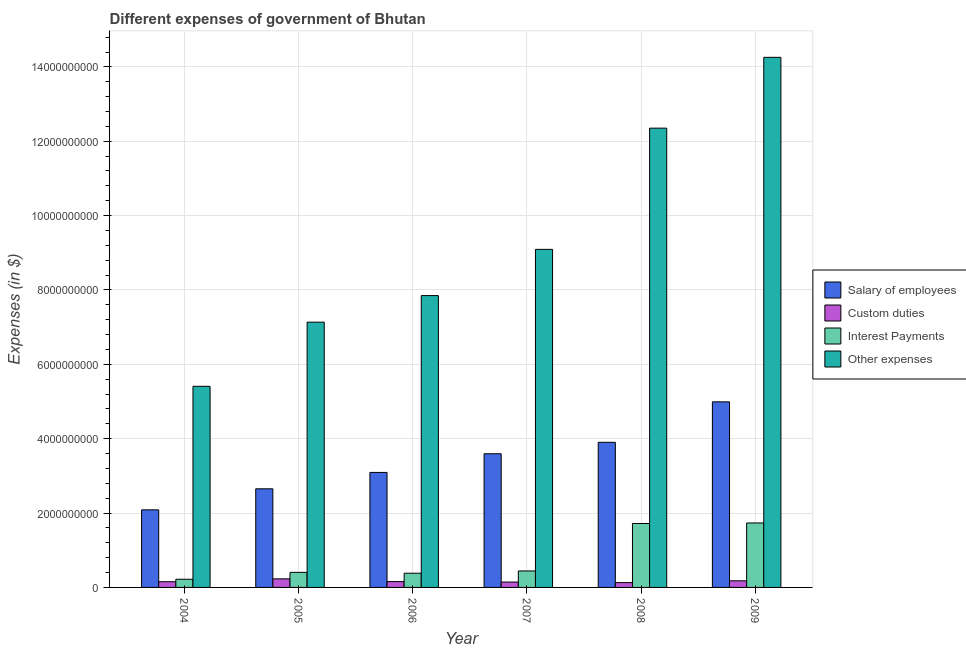How many different coloured bars are there?
Make the answer very short. 4. Are the number of bars per tick equal to the number of legend labels?
Provide a short and direct response. Yes. Are the number of bars on each tick of the X-axis equal?
Provide a short and direct response. Yes. How many bars are there on the 5th tick from the right?
Your answer should be compact. 4. What is the label of the 2nd group of bars from the left?
Offer a very short reply. 2005. What is the amount spent on other expenses in 2004?
Give a very brief answer. 5.41e+09. Across all years, what is the maximum amount spent on other expenses?
Your answer should be compact. 1.43e+1. Across all years, what is the minimum amount spent on other expenses?
Your answer should be very brief. 5.41e+09. In which year was the amount spent on custom duties maximum?
Provide a short and direct response. 2005. In which year was the amount spent on salary of employees minimum?
Offer a terse response. 2004. What is the total amount spent on custom duties in the graph?
Your response must be concise. 9.93e+08. What is the difference between the amount spent on custom duties in 2005 and that in 2009?
Give a very brief answer. 5.28e+07. What is the difference between the amount spent on salary of employees in 2005 and the amount spent on custom duties in 2004?
Keep it short and to the point. 5.66e+08. What is the average amount spent on interest payments per year?
Offer a very short reply. 8.17e+08. In the year 2005, what is the difference between the amount spent on salary of employees and amount spent on custom duties?
Provide a succinct answer. 0. What is the ratio of the amount spent on other expenses in 2004 to that in 2009?
Provide a succinct answer. 0.38. Is the amount spent on custom duties in 2006 less than that in 2007?
Make the answer very short. No. What is the difference between the highest and the second highest amount spent on custom duties?
Your response must be concise. 5.28e+07. What is the difference between the highest and the lowest amount spent on interest payments?
Your answer should be very brief. 1.51e+09. Is it the case that in every year, the sum of the amount spent on salary of employees and amount spent on interest payments is greater than the sum of amount spent on other expenses and amount spent on custom duties?
Your answer should be compact. Yes. What does the 4th bar from the left in 2006 represents?
Keep it short and to the point. Other expenses. What does the 1st bar from the right in 2006 represents?
Your answer should be compact. Other expenses. Is it the case that in every year, the sum of the amount spent on salary of employees and amount spent on custom duties is greater than the amount spent on interest payments?
Your answer should be very brief. Yes. How many bars are there?
Offer a terse response. 24. What is the difference between two consecutive major ticks on the Y-axis?
Provide a short and direct response. 2.00e+09. Are the values on the major ticks of Y-axis written in scientific E-notation?
Your answer should be very brief. No. Does the graph contain any zero values?
Your response must be concise. No. Where does the legend appear in the graph?
Give a very brief answer. Center right. What is the title of the graph?
Give a very brief answer. Different expenses of government of Bhutan. What is the label or title of the Y-axis?
Provide a short and direct response. Expenses (in $). What is the Expenses (in $) of Salary of employees in 2004?
Your response must be concise. 2.09e+09. What is the Expenses (in $) of Custom duties in 2004?
Ensure brevity in your answer.  1.53e+08. What is the Expenses (in $) in Interest Payments in 2004?
Keep it short and to the point. 2.20e+08. What is the Expenses (in $) of Other expenses in 2004?
Keep it short and to the point. 5.41e+09. What is the Expenses (in $) of Salary of employees in 2005?
Provide a short and direct response. 2.65e+09. What is the Expenses (in $) of Custom duties in 2005?
Give a very brief answer. 2.31e+08. What is the Expenses (in $) in Interest Payments in 2005?
Provide a short and direct response. 4.05e+08. What is the Expenses (in $) in Other expenses in 2005?
Keep it short and to the point. 7.13e+09. What is the Expenses (in $) in Salary of employees in 2006?
Your answer should be compact. 3.09e+09. What is the Expenses (in $) in Custom duties in 2006?
Provide a short and direct response. 1.57e+08. What is the Expenses (in $) of Interest Payments in 2006?
Your answer should be very brief. 3.82e+08. What is the Expenses (in $) in Other expenses in 2006?
Give a very brief answer. 7.85e+09. What is the Expenses (in $) in Salary of employees in 2007?
Make the answer very short. 3.60e+09. What is the Expenses (in $) of Custom duties in 2007?
Ensure brevity in your answer.  1.45e+08. What is the Expenses (in $) of Interest Payments in 2007?
Keep it short and to the point. 4.43e+08. What is the Expenses (in $) in Other expenses in 2007?
Make the answer very short. 9.09e+09. What is the Expenses (in $) of Salary of employees in 2008?
Provide a succinct answer. 3.90e+09. What is the Expenses (in $) in Custom duties in 2008?
Give a very brief answer. 1.29e+08. What is the Expenses (in $) in Interest Payments in 2008?
Keep it short and to the point. 1.72e+09. What is the Expenses (in $) of Other expenses in 2008?
Your answer should be compact. 1.24e+1. What is the Expenses (in $) of Salary of employees in 2009?
Your answer should be very brief. 4.99e+09. What is the Expenses (in $) in Custom duties in 2009?
Your answer should be very brief. 1.78e+08. What is the Expenses (in $) of Interest Payments in 2009?
Provide a short and direct response. 1.73e+09. What is the Expenses (in $) of Other expenses in 2009?
Offer a terse response. 1.43e+1. Across all years, what is the maximum Expenses (in $) of Salary of employees?
Provide a short and direct response. 4.99e+09. Across all years, what is the maximum Expenses (in $) of Custom duties?
Offer a very short reply. 2.31e+08. Across all years, what is the maximum Expenses (in $) of Interest Payments?
Ensure brevity in your answer.  1.73e+09. Across all years, what is the maximum Expenses (in $) in Other expenses?
Your response must be concise. 1.43e+1. Across all years, what is the minimum Expenses (in $) in Salary of employees?
Offer a very short reply. 2.09e+09. Across all years, what is the minimum Expenses (in $) in Custom duties?
Ensure brevity in your answer.  1.29e+08. Across all years, what is the minimum Expenses (in $) of Interest Payments?
Your answer should be compact. 2.20e+08. Across all years, what is the minimum Expenses (in $) in Other expenses?
Offer a terse response. 5.41e+09. What is the total Expenses (in $) of Salary of employees in the graph?
Provide a short and direct response. 2.03e+1. What is the total Expenses (in $) of Custom duties in the graph?
Give a very brief answer. 9.93e+08. What is the total Expenses (in $) in Interest Payments in the graph?
Your response must be concise. 4.90e+09. What is the total Expenses (in $) of Other expenses in the graph?
Keep it short and to the point. 5.61e+1. What is the difference between the Expenses (in $) of Salary of employees in 2004 and that in 2005?
Provide a succinct answer. -5.66e+08. What is the difference between the Expenses (in $) in Custom duties in 2004 and that in 2005?
Your answer should be compact. -7.75e+07. What is the difference between the Expenses (in $) of Interest Payments in 2004 and that in 2005?
Your answer should be compact. -1.85e+08. What is the difference between the Expenses (in $) in Other expenses in 2004 and that in 2005?
Offer a very short reply. -1.72e+09. What is the difference between the Expenses (in $) of Salary of employees in 2004 and that in 2006?
Offer a very short reply. -1.01e+09. What is the difference between the Expenses (in $) in Custom duties in 2004 and that in 2006?
Offer a terse response. -3.86e+06. What is the difference between the Expenses (in $) of Interest Payments in 2004 and that in 2006?
Your response must be concise. -1.62e+08. What is the difference between the Expenses (in $) of Other expenses in 2004 and that in 2006?
Your answer should be compact. -2.44e+09. What is the difference between the Expenses (in $) in Salary of employees in 2004 and that in 2007?
Give a very brief answer. -1.51e+09. What is the difference between the Expenses (in $) in Custom duties in 2004 and that in 2007?
Your answer should be very brief. 8.63e+06. What is the difference between the Expenses (in $) in Interest Payments in 2004 and that in 2007?
Offer a very short reply. -2.23e+08. What is the difference between the Expenses (in $) in Other expenses in 2004 and that in 2007?
Offer a terse response. -3.68e+09. What is the difference between the Expenses (in $) of Salary of employees in 2004 and that in 2008?
Ensure brevity in your answer.  -1.82e+09. What is the difference between the Expenses (in $) in Custom duties in 2004 and that in 2008?
Your answer should be very brief. 2.38e+07. What is the difference between the Expenses (in $) of Interest Payments in 2004 and that in 2008?
Ensure brevity in your answer.  -1.50e+09. What is the difference between the Expenses (in $) of Other expenses in 2004 and that in 2008?
Your answer should be very brief. -6.94e+09. What is the difference between the Expenses (in $) in Salary of employees in 2004 and that in 2009?
Provide a succinct answer. -2.90e+09. What is the difference between the Expenses (in $) of Custom duties in 2004 and that in 2009?
Ensure brevity in your answer.  -2.46e+07. What is the difference between the Expenses (in $) of Interest Payments in 2004 and that in 2009?
Ensure brevity in your answer.  -1.51e+09. What is the difference between the Expenses (in $) in Other expenses in 2004 and that in 2009?
Make the answer very short. -8.85e+09. What is the difference between the Expenses (in $) of Salary of employees in 2005 and that in 2006?
Your answer should be very brief. -4.40e+08. What is the difference between the Expenses (in $) of Custom duties in 2005 and that in 2006?
Keep it short and to the point. 7.36e+07. What is the difference between the Expenses (in $) in Interest Payments in 2005 and that in 2006?
Provide a short and direct response. 2.33e+07. What is the difference between the Expenses (in $) of Other expenses in 2005 and that in 2006?
Give a very brief answer. -7.15e+08. What is the difference between the Expenses (in $) of Salary of employees in 2005 and that in 2007?
Give a very brief answer. -9.43e+08. What is the difference between the Expenses (in $) of Custom duties in 2005 and that in 2007?
Give a very brief answer. 8.61e+07. What is the difference between the Expenses (in $) in Interest Payments in 2005 and that in 2007?
Offer a very short reply. -3.78e+07. What is the difference between the Expenses (in $) in Other expenses in 2005 and that in 2007?
Provide a short and direct response. -1.96e+09. What is the difference between the Expenses (in $) in Salary of employees in 2005 and that in 2008?
Provide a short and direct response. -1.25e+09. What is the difference between the Expenses (in $) in Custom duties in 2005 and that in 2008?
Offer a terse response. 1.01e+08. What is the difference between the Expenses (in $) in Interest Payments in 2005 and that in 2008?
Offer a terse response. -1.31e+09. What is the difference between the Expenses (in $) of Other expenses in 2005 and that in 2008?
Make the answer very short. -5.22e+09. What is the difference between the Expenses (in $) in Salary of employees in 2005 and that in 2009?
Offer a terse response. -2.34e+09. What is the difference between the Expenses (in $) of Custom duties in 2005 and that in 2009?
Your answer should be compact. 5.28e+07. What is the difference between the Expenses (in $) in Interest Payments in 2005 and that in 2009?
Provide a short and direct response. -1.33e+09. What is the difference between the Expenses (in $) in Other expenses in 2005 and that in 2009?
Your response must be concise. -7.12e+09. What is the difference between the Expenses (in $) of Salary of employees in 2006 and that in 2007?
Your response must be concise. -5.02e+08. What is the difference between the Expenses (in $) of Custom duties in 2006 and that in 2007?
Your answer should be compact. 1.25e+07. What is the difference between the Expenses (in $) in Interest Payments in 2006 and that in 2007?
Your answer should be compact. -6.12e+07. What is the difference between the Expenses (in $) of Other expenses in 2006 and that in 2007?
Make the answer very short. -1.24e+09. What is the difference between the Expenses (in $) of Salary of employees in 2006 and that in 2008?
Your answer should be compact. -8.10e+08. What is the difference between the Expenses (in $) in Custom duties in 2006 and that in 2008?
Offer a very short reply. 2.77e+07. What is the difference between the Expenses (in $) in Interest Payments in 2006 and that in 2008?
Ensure brevity in your answer.  -1.34e+09. What is the difference between the Expenses (in $) in Other expenses in 2006 and that in 2008?
Offer a terse response. -4.50e+09. What is the difference between the Expenses (in $) of Salary of employees in 2006 and that in 2009?
Give a very brief answer. -1.90e+09. What is the difference between the Expenses (in $) of Custom duties in 2006 and that in 2009?
Your response must be concise. -2.08e+07. What is the difference between the Expenses (in $) in Interest Payments in 2006 and that in 2009?
Offer a very short reply. -1.35e+09. What is the difference between the Expenses (in $) in Other expenses in 2006 and that in 2009?
Provide a succinct answer. -6.41e+09. What is the difference between the Expenses (in $) of Salary of employees in 2007 and that in 2008?
Provide a succinct answer. -3.08e+08. What is the difference between the Expenses (in $) in Custom duties in 2007 and that in 2008?
Your response must be concise. 1.52e+07. What is the difference between the Expenses (in $) in Interest Payments in 2007 and that in 2008?
Provide a short and direct response. -1.28e+09. What is the difference between the Expenses (in $) of Other expenses in 2007 and that in 2008?
Your response must be concise. -3.26e+09. What is the difference between the Expenses (in $) of Salary of employees in 2007 and that in 2009?
Offer a terse response. -1.40e+09. What is the difference between the Expenses (in $) of Custom duties in 2007 and that in 2009?
Make the answer very short. -3.33e+07. What is the difference between the Expenses (in $) in Interest Payments in 2007 and that in 2009?
Make the answer very short. -1.29e+09. What is the difference between the Expenses (in $) of Other expenses in 2007 and that in 2009?
Offer a terse response. -5.16e+09. What is the difference between the Expenses (in $) of Salary of employees in 2008 and that in 2009?
Ensure brevity in your answer.  -1.09e+09. What is the difference between the Expenses (in $) of Custom duties in 2008 and that in 2009?
Give a very brief answer. -4.85e+07. What is the difference between the Expenses (in $) of Interest Payments in 2008 and that in 2009?
Provide a succinct answer. -1.46e+07. What is the difference between the Expenses (in $) of Other expenses in 2008 and that in 2009?
Your answer should be compact. -1.90e+09. What is the difference between the Expenses (in $) in Salary of employees in 2004 and the Expenses (in $) in Custom duties in 2005?
Provide a short and direct response. 1.86e+09. What is the difference between the Expenses (in $) in Salary of employees in 2004 and the Expenses (in $) in Interest Payments in 2005?
Provide a succinct answer. 1.68e+09. What is the difference between the Expenses (in $) of Salary of employees in 2004 and the Expenses (in $) of Other expenses in 2005?
Your response must be concise. -5.05e+09. What is the difference between the Expenses (in $) in Custom duties in 2004 and the Expenses (in $) in Interest Payments in 2005?
Provide a short and direct response. -2.52e+08. What is the difference between the Expenses (in $) in Custom duties in 2004 and the Expenses (in $) in Other expenses in 2005?
Offer a very short reply. -6.98e+09. What is the difference between the Expenses (in $) of Interest Payments in 2004 and the Expenses (in $) of Other expenses in 2005?
Offer a terse response. -6.91e+09. What is the difference between the Expenses (in $) in Salary of employees in 2004 and the Expenses (in $) in Custom duties in 2006?
Keep it short and to the point. 1.93e+09. What is the difference between the Expenses (in $) of Salary of employees in 2004 and the Expenses (in $) of Interest Payments in 2006?
Your response must be concise. 1.70e+09. What is the difference between the Expenses (in $) in Salary of employees in 2004 and the Expenses (in $) in Other expenses in 2006?
Provide a succinct answer. -5.76e+09. What is the difference between the Expenses (in $) in Custom duties in 2004 and the Expenses (in $) in Interest Payments in 2006?
Offer a terse response. -2.29e+08. What is the difference between the Expenses (in $) in Custom duties in 2004 and the Expenses (in $) in Other expenses in 2006?
Your response must be concise. -7.70e+09. What is the difference between the Expenses (in $) in Interest Payments in 2004 and the Expenses (in $) in Other expenses in 2006?
Keep it short and to the point. -7.63e+09. What is the difference between the Expenses (in $) of Salary of employees in 2004 and the Expenses (in $) of Custom duties in 2007?
Ensure brevity in your answer.  1.94e+09. What is the difference between the Expenses (in $) of Salary of employees in 2004 and the Expenses (in $) of Interest Payments in 2007?
Ensure brevity in your answer.  1.64e+09. What is the difference between the Expenses (in $) in Salary of employees in 2004 and the Expenses (in $) in Other expenses in 2007?
Give a very brief answer. -7.01e+09. What is the difference between the Expenses (in $) of Custom duties in 2004 and the Expenses (in $) of Interest Payments in 2007?
Provide a short and direct response. -2.90e+08. What is the difference between the Expenses (in $) in Custom duties in 2004 and the Expenses (in $) in Other expenses in 2007?
Give a very brief answer. -8.94e+09. What is the difference between the Expenses (in $) in Interest Payments in 2004 and the Expenses (in $) in Other expenses in 2007?
Ensure brevity in your answer.  -8.87e+09. What is the difference between the Expenses (in $) in Salary of employees in 2004 and the Expenses (in $) in Custom duties in 2008?
Make the answer very short. 1.96e+09. What is the difference between the Expenses (in $) in Salary of employees in 2004 and the Expenses (in $) in Interest Payments in 2008?
Provide a succinct answer. 3.68e+08. What is the difference between the Expenses (in $) in Salary of employees in 2004 and the Expenses (in $) in Other expenses in 2008?
Offer a very short reply. -1.03e+1. What is the difference between the Expenses (in $) of Custom duties in 2004 and the Expenses (in $) of Interest Payments in 2008?
Provide a succinct answer. -1.57e+09. What is the difference between the Expenses (in $) in Custom duties in 2004 and the Expenses (in $) in Other expenses in 2008?
Give a very brief answer. -1.22e+1. What is the difference between the Expenses (in $) of Interest Payments in 2004 and the Expenses (in $) of Other expenses in 2008?
Give a very brief answer. -1.21e+1. What is the difference between the Expenses (in $) of Salary of employees in 2004 and the Expenses (in $) of Custom duties in 2009?
Offer a very short reply. 1.91e+09. What is the difference between the Expenses (in $) in Salary of employees in 2004 and the Expenses (in $) in Interest Payments in 2009?
Offer a very short reply. 3.53e+08. What is the difference between the Expenses (in $) of Salary of employees in 2004 and the Expenses (in $) of Other expenses in 2009?
Provide a succinct answer. -1.22e+1. What is the difference between the Expenses (in $) of Custom duties in 2004 and the Expenses (in $) of Interest Payments in 2009?
Give a very brief answer. -1.58e+09. What is the difference between the Expenses (in $) of Custom duties in 2004 and the Expenses (in $) of Other expenses in 2009?
Keep it short and to the point. -1.41e+1. What is the difference between the Expenses (in $) in Interest Payments in 2004 and the Expenses (in $) in Other expenses in 2009?
Provide a succinct answer. -1.40e+1. What is the difference between the Expenses (in $) of Salary of employees in 2005 and the Expenses (in $) of Custom duties in 2006?
Make the answer very short. 2.50e+09. What is the difference between the Expenses (in $) in Salary of employees in 2005 and the Expenses (in $) in Interest Payments in 2006?
Offer a very short reply. 2.27e+09. What is the difference between the Expenses (in $) of Salary of employees in 2005 and the Expenses (in $) of Other expenses in 2006?
Offer a very short reply. -5.20e+09. What is the difference between the Expenses (in $) in Custom duties in 2005 and the Expenses (in $) in Interest Payments in 2006?
Ensure brevity in your answer.  -1.51e+08. What is the difference between the Expenses (in $) of Custom duties in 2005 and the Expenses (in $) of Other expenses in 2006?
Make the answer very short. -7.62e+09. What is the difference between the Expenses (in $) in Interest Payments in 2005 and the Expenses (in $) in Other expenses in 2006?
Your answer should be very brief. -7.44e+09. What is the difference between the Expenses (in $) of Salary of employees in 2005 and the Expenses (in $) of Custom duties in 2007?
Keep it short and to the point. 2.51e+09. What is the difference between the Expenses (in $) of Salary of employees in 2005 and the Expenses (in $) of Interest Payments in 2007?
Your answer should be very brief. 2.21e+09. What is the difference between the Expenses (in $) in Salary of employees in 2005 and the Expenses (in $) in Other expenses in 2007?
Ensure brevity in your answer.  -6.44e+09. What is the difference between the Expenses (in $) of Custom duties in 2005 and the Expenses (in $) of Interest Payments in 2007?
Your answer should be compact. -2.13e+08. What is the difference between the Expenses (in $) of Custom duties in 2005 and the Expenses (in $) of Other expenses in 2007?
Provide a succinct answer. -8.86e+09. What is the difference between the Expenses (in $) of Interest Payments in 2005 and the Expenses (in $) of Other expenses in 2007?
Your answer should be very brief. -8.69e+09. What is the difference between the Expenses (in $) of Salary of employees in 2005 and the Expenses (in $) of Custom duties in 2008?
Offer a terse response. 2.52e+09. What is the difference between the Expenses (in $) of Salary of employees in 2005 and the Expenses (in $) of Interest Payments in 2008?
Your answer should be compact. 9.33e+08. What is the difference between the Expenses (in $) of Salary of employees in 2005 and the Expenses (in $) of Other expenses in 2008?
Provide a succinct answer. -9.70e+09. What is the difference between the Expenses (in $) in Custom duties in 2005 and the Expenses (in $) in Interest Payments in 2008?
Offer a terse response. -1.49e+09. What is the difference between the Expenses (in $) in Custom duties in 2005 and the Expenses (in $) in Other expenses in 2008?
Provide a short and direct response. -1.21e+1. What is the difference between the Expenses (in $) in Interest Payments in 2005 and the Expenses (in $) in Other expenses in 2008?
Make the answer very short. -1.19e+1. What is the difference between the Expenses (in $) of Salary of employees in 2005 and the Expenses (in $) of Custom duties in 2009?
Your response must be concise. 2.47e+09. What is the difference between the Expenses (in $) in Salary of employees in 2005 and the Expenses (in $) in Interest Payments in 2009?
Offer a very short reply. 9.19e+08. What is the difference between the Expenses (in $) in Salary of employees in 2005 and the Expenses (in $) in Other expenses in 2009?
Your response must be concise. -1.16e+1. What is the difference between the Expenses (in $) of Custom duties in 2005 and the Expenses (in $) of Interest Payments in 2009?
Provide a succinct answer. -1.50e+09. What is the difference between the Expenses (in $) in Custom duties in 2005 and the Expenses (in $) in Other expenses in 2009?
Make the answer very short. -1.40e+1. What is the difference between the Expenses (in $) of Interest Payments in 2005 and the Expenses (in $) of Other expenses in 2009?
Provide a succinct answer. -1.39e+1. What is the difference between the Expenses (in $) in Salary of employees in 2006 and the Expenses (in $) in Custom duties in 2007?
Offer a terse response. 2.95e+09. What is the difference between the Expenses (in $) in Salary of employees in 2006 and the Expenses (in $) in Interest Payments in 2007?
Keep it short and to the point. 2.65e+09. What is the difference between the Expenses (in $) in Salary of employees in 2006 and the Expenses (in $) in Other expenses in 2007?
Offer a very short reply. -6.00e+09. What is the difference between the Expenses (in $) of Custom duties in 2006 and the Expenses (in $) of Interest Payments in 2007?
Give a very brief answer. -2.86e+08. What is the difference between the Expenses (in $) in Custom duties in 2006 and the Expenses (in $) in Other expenses in 2007?
Offer a terse response. -8.93e+09. What is the difference between the Expenses (in $) of Interest Payments in 2006 and the Expenses (in $) of Other expenses in 2007?
Provide a succinct answer. -8.71e+09. What is the difference between the Expenses (in $) of Salary of employees in 2006 and the Expenses (in $) of Custom duties in 2008?
Provide a succinct answer. 2.96e+09. What is the difference between the Expenses (in $) in Salary of employees in 2006 and the Expenses (in $) in Interest Payments in 2008?
Provide a short and direct response. 1.37e+09. What is the difference between the Expenses (in $) of Salary of employees in 2006 and the Expenses (in $) of Other expenses in 2008?
Offer a terse response. -9.26e+09. What is the difference between the Expenses (in $) in Custom duties in 2006 and the Expenses (in $) in Interest Payments in 2008?
Provide a succinct answer. -1.56e+09. What is the difference between the Expenses (in $) in Custom duties in 2006 and the Expenses (in $) in Other expenses in 2008?
Your response must be concise. -1.22e+1. What is the difference between the Expenses (in $) in Interest Payments in 2006 and the Expenses (in $) in Other expenses in 2008?
Ensure brevity in your answer.  -1.20e+1. What is the difference between the Expenses (in $) in Salary of employees in 2006 and the Expenses (in $) in Custom duties in 2009?
Your response must be concise. 2.91e+09. What is the difference between the Expenses (in $) in Salary of employees in 2006 and the Expenses (in $) in Interest Payments in 2009?
Ensure brevity in your answer.  1.36e+09. What is the difference between the Expenses (in $) of Salary of employees in 2006 and the Expenses (in $) of Other expenses in 2009?
Provide a succinct answer. -1.12e+1. What is the difference between the Expenses (in $) in Custom duties in 2006 and the Expenses (in $) in Interest Payments in 2009?
Keep it short and to the point. -1.58e+09. What is the difference between the Expenses (in $) of Custom duties in 2006 and the Expenses (in $) of Other expenses in 2009?
Provide a short and direct response. -1.41e+1. What is the difference between the Expenses (in $) in Interest Payments in 2006 and the Expenses (in $) in Other expenses in 2009?
Keep it short and to the point. -1.39e+1. What is the difference between the Expenses (in $) in Salary of employees in 2007 and the Expenses (in $) in Custom duties in 2008?
Your response must be concise. 3.47e+09. What is the difference between the Expenses (in $) in Salary of employees in 2007 and the Expenses (in $) in Interest Payments in 2008?
Your response must be concise. 1.88e+09. What is the difference between the Expenses (in $) in Salary of employees in 2007 and the Expenses (in $) in Other expenses in 2008?
Make the answer very short. -8.76e+09. What is the difference between the Expenses (in $) of Custom duties in 2007 and the Expenses (in $) of Interest Payments in 2008?
Keep it short and to the point. -1.57e+09. What is the difference between the Expenses (in $) of Custom duties in 2007 and the Expenses (in $) of Other expenses in 2008?
Ensure brevity in your answer.  -1.22e+1. What is the difference between the Expenses (in $) of Interest Payments in 2007 and the Expenses (in $) of Other expenses in 2008?
Ensure brevity in your answer.  -1.19e+1. What is the difference between the Expenses (in $) of Salary of employees in 2007 and the Expenses (in $) of Custom duties in 2009?
Your answer should be very brief. 3.42e+09. What is the difference between the Expenses (in $) in Salary of employees in 2007 and the Expenses (in $) in Interest Payments in 2009?
Offer a very short reply. 1.86e+09. What is the difference between the Expenses (in $) in Salary of employees in 2007 and the Expenses (in $) in Other expenses in 2009?
Your answer should be very brief. -1.07e+1. What is the difference between the Expenses (in $) in Custom duties in 2007 and the Expenses (in $) in Interest Payments in 2009?
Offer a terse response. -1.59e+09. What is the difference between the Expenses (in $) of Custom duties in 2007 and the Expenses (in $) of Other expenses in 2009?
Offer a terse response. -1.41e+1. What is the difference between the Expenses (in $) of Interest Payments in 2007 and the Expenses (in $) of Other expenses in 2009?
Offer a terse response. -1.38e+1. What is the difference between the Expenses (in $) of Salary of employees in 2008 and the Expenses (in $) of Custom duties in 2009?
Give a very brief answer. 3.73e+09. What is the difference between the Expenses (in $) of Salary of employees in 2008 and the Expenses (in $) of Interest Payments in 2009?
Provide a short and direct response. 2.17e+09. What is the difference between the Expenses (in $) of Salary of employees in 2008 and the Expenses (in $) of Other expenses in 2009?
Provide a short and direct response. -1.04e+1. What is the difference between the Expenses (in $) in Custom duties in 2008 and the Expenses (in $) in Interest Payments in 2009?
Keep it short and to the point. -1.60e+09. What is the difference between the Expenses (in $) of Custom duties in 2008 and the Expenses (in $) of Other expenses in 2009?
Ensure brevity in your answer.  -1.41e+1. What is the difference between the Expenses (in $) in Interest Payments in 2008 and the Expenses (in $) in Other expenses in 2009?
Your answer should be very brief. -1.25e+1. What is the average Expenses (in $) in Salary of employees per year?
Your answer should be very brief. 3.39e+09. What is the average Expenses (in $) of Custom duties per year?
Your answer should be very brief. 1.66e+08. What is the average Expenses (in $) of Interest Payments per year?
Your answer should be very brief. 8.17e+08. What is the average Expenses (in $) in Other expenses per year?
Your response must be concise. 9.35e+09. In the year 2004, what is the difference between the Expenses (in $) in Salary of employees and Expenses (in $) in Custom duties?
Provide a succinct answer. 1.93e+09. In the year 2004, what is the difference between the Expenses (in $) of Salary of employees and Expenses (in $) of Interest Payments?
Offer a terse response. 1.87e+09. In the year 2004, what is the difference between the Expenses (in $) of Salary of employees and Expenses (in $) of Other expenses?
Your answer should be very brief. -3.32e+09. In the year 2004, what is the difference between the Expenses (in $) in Custom duties and Expenses (in $) in Interest Payments?
Keep it short and to the point. -6.69e+07. In the year 2004, what is the difference between the Expenses (in $) in Custom duties and Expenses (in $) in Other expenses?
Give a very brief answer. -5.26e+09. In the year 2004, what is the difference between the Expenses (in $) of Interest Payments and Expenses (in $) of Other expenses?
Provide a short and direct response. -5.19e+09. In the year 2005, what is the difference between the Expenses (in $) of Salary of employees and Expenses (in $) of Custom duties?
Offer a terse response. 2.42e+09. In the year 2005, what is the difference between the Expenses (in $) of Salary of employees and Expenses (in $) of Interest Payments?
Your answer should be very brief. 2.25e+09. In the year 2005, what is the difference between the Expenses (in $) of Salary of employees and Expenses (in $) of Other expenses?
Give a very brief answer. -4.48e+09. In the year 2005, what is the difference between the Expenses (in $) in Custom duties and Expenses (in $) in Interest Payments?
Keep it short and to the point. -1.75e+08. In the year 2005, what is the difference between the Expenses (in $) in Custom duties and Expenses (in $) in Other expenses?
Your answer should be compact. -6.90e+09. In the year 2005, what is the difference between the Expenses (in $) in Interest Payments and Expenses (in $) in Other expenses?
Your answer should be very brief. -6.73e+09. In the year 2006, what is the difference between the Expenses (in $) in Salary of employees and Expenses (in $) in Custom duties?
Offer a terse response. 2.94e+09. In the year 2006, what is the difference between the Expenses (in $) of Salary of employees and Expenses (in $) of Interest Payments?
Your answer should be compact. 2.71e+09. In the year 2006, what is the difference between the Expenses (in $) of Salary of employees and Expenses (in $) of Other expenses?
Your answer should be very brief. -4.76e+09. In the year 2006, what is the difference between the Expenses (in $) of Custom duties and Expenses (in $) of Interest Payments?
Offer a terse response. -2.25e+08. In the year 2006, what is the difference between the Expenses (in $) in Custom duties and Expenses (in $) in Other expenses?
Make the answer very short. -7.69e+09. In the year 2006, what is the difference between the Expenses (in $) of Interest Payments and Expenses (in $) of Other expenses?
Your answer should be compact. -7.47e+09. In the year 2007, what is the difference between the Expenses (in $) of Salary of employees and Expenses (in $) of Custom duties?
Ensure brevity in your answer.  3.45e+09. In the year 2007, what is the difference between the Expenses (in $) in Salary of employees and Expenses (in $) in Interest Payments?
Provide a short and direct response. 3.15e+09. In the year 2007, what is the difference between the Expenses (in $) of Salary of employees and Expenses (in $) of Other expenses?
Ensure brevity in your answer.  -5.50e+09. In the year 2007, what is the difference between the Expenses (in $) of Custom duties and Expenses (in $) of Interest Payments?
Ensure brevity in your answer.  -2.99e+08. In the year 2007, what is the difference between the Expenses (in $) in Custom duties and Expenses (in $) in Other expenses?
Make the answer very short. -8.95e+09. In the year 2007, what is the difference between the Expenses (in $) of Interest Payments and Expenses (in $) of Other expenses?
Offer a terse response. -8.65e+09. In the year 2008, what is the difference between the Expenses (in $) in Salary of employees and Expenses (in $) in Custom duties?
Keep it short and to the point. 3.77e+09. In the year 2008, what is the difference between the Expenses (in $) in Salary of employees and Expenses (in $) in Interest Payments?
Give a very brief answer. 2.18e+09. In the year 2008, what is the difference between the Expenses (in $) in Salary of employees and Expenses (in $) in Other expenses?
Give a very brief answer. -8.45e+09. In the year 2008, what is the difference between the Expenses (in $) in Custom duties and Expenses (in $) in Interest Payments?
Your answer should be compact. -1.59e+09. In the year 2008, what is the difference between the Expenses (in $) of Custom duties and Expenses (in $) of Other expenses?
Offer a terse response. -1.22e+1. In the year 2008, what is the difference between the Expenses (in $) in Interest Payments and Expenses (in $) in Other expenses?
Ensure brevity in your answer.  -1.06e+1. In the year 2009, what is the difference between the Expenses (in $) of Salary of employees and Expenses (in $) of Custom duties?
Offer a terse response. 4.81e+09. In the year 2009, what is the difference between the Expenses (in $) in Salary of employees and Expenses (in $) in Interest Payments?
Give a very brief answer. 3.26e+09. In the year 2009, what is the difference between the Expenses (in $) in Salary of employees and Expenses (in $) in Other expenses?
Offer a terse response. -9.27e+09. In the year 2009, what is the difference between the Expenses (in $) of Custom duties and Expenses (in $) of Interest Payments?
Your answer should be compact. -1.56e+09. In the year 2009, what is the difference between the Expenses (in $) of Custom duties and Expenses (in $) of Other expenses?
Provide a short and direct response. -1.41e+1. In the year 2009, what is the difference between the Expenses (in $) in Interest Payments and Expenses (in $) in Other expenses?
Provide a short and direct response. -1.25e+1. What is the ratio of the Expenses (in $) of Salary of employees in 2004 to that in 2005?
Make the answer very short. 0.79. What is the ratio of the Expenses (in $) in Custom duties in 2004 to that in 2005?
Provide a short and direct response. 0.66. What is the ratio of the Expenses (in $) of Interest Payments in 2004 to that in 2005?
Give a very brief answer. 0.54. What is the ratio of the Expenses (in $) of Other expenses in 2004 to that in 2005?
Provide a succinct answer. 0.76. What is the ratio of the Expenses (in $) of Salary of employees in 2004 to that in 2006?
Offer a terse response. 0.67. What is the ratio of the Expenses (in $) in Custom duties in 2004 to that in 2006?
Your response must be concise. 0.98. What is the ratio of the Expenses (in $) in Interest Payments in 2004 to that in 2006?
Offer a very short reply. 0.58. What is the ratio of the Expenses (in $) of Other expenses in 2004 to that in 2006?
Your answer should be compact. 0.69. What is the ratio of the Expenses (in $) of Salary of employees in 2004 to that in 2007?
Your response must be concise. 0.58. What is the ratio of the Expenses (in $) of Custom duties in 2004 to that in 2007?
Make the answer very short. 1.06. What is the ratio of the Expenses (in $) in Interest Payments in 2004 to that in 2007?
Offer a very short reply. 0.5. What is the ratio of the Expenses (in $) of Other expenses in 2004 to that in 2007?
Offer a terse response. 0.59. What is the ratio of the Expenses (in $) of Salary of employees in 2004 to that in 2008?
Your response must be concise. 0.53. What is the ratio of the Expenses (in $) in Custom duties in 2004 to that in 2008?
Make the answer very short. 1.18. What is the ratio of the Expenses (in $) of Interest Payments in 2004 to that in 2008?
Your answer should be compact. 0.13. What is the ratio of the Expenses (in $) of Other expenses in 2004 to that in 2008?
Your answer should be compact. 0.44. What is the ratio of the Expenses (in $) of Salary of employees in 2004 to that in 2009?
Your answer should be compact. 0.42. What is the ratio of the Expenses (in $) of Custom duties in 2004 to that in 2009?
Your answer should be compact. 0.86. What is the ratio of the Expenses (in $) in Interest Payments in 2004 to that in 2009?
Keep it short and to the point. 0.13. What is the ratio of the Expenses (in $) of Other expenses in 2004 to that in 2009?
Offer a terse response. 0.38. What is the ratio of the Expenses (in $) of Salary of employees in 2005 to that in 2006?
Your response must be concise. 0.86. What is the ratio of the Expenses (in $) of Custom duties in 2005 to that in 2006?
Provide a short and direct response. 1.47. What is the ratio of the Expenses (in $) of Interest Payments in 2005 to that in 2006?
Ensure brevity in your answer.  1.06. What is the ratio of the Expenses (in $) in Other expenses in 2005 to that in 2006?
Provide a short and direct response. 0.91. What is the ratio of the Expenses (in $) of Salary of employees in 2005 to that in 2007?
Offer a terse response. 0.74. What is the ratio of the Expenses (in $) in Custom duties in 2005 to that in 2007?
Provide a succinct answer. 1.59. What is the ratio of the Expenses (in $) in Interest Payments in 2005 to that in 2007?
Provide a short and direct response. 0.91. What is the ratio of the Expenses (in $) in Other expenses in 2005 to that in 2007?
Keep it short and to the point. 0.78. What is the ratio of the Expenses (in $) in Salary of employees in 2005 to that in 2008?
Make the answer very short. 0.68. What is the ratio of the Expenses (in $) in Custom duties in 2005 to that in 2008?
Your answer should be very brief. 1.78. What is the ratio of the Expenses (in $) in Interest Payments in 2005 to that in 2008?
Provide a succinct answer. 0.24. What is the ratio of the Expenses (in $) of Other expenses in 2005 to that in 2008?
Keep it short and to the point. 0.58. What is the ratio of the Expenses (in $) of Salary of employees in 2005 to that in 2009?
Offer a terse response. 0.53. What is the ratio of the Expenses (in $) in Custom duties in 2005 to that in 2009?
Keep it short and to the point. 1.3. What is the ratio of the Expenses (in $) in Interest Payments in 2005 to that in 2009?
Give a very brief answer. 0.23. What is the ratio of the Expenses (in $) in Other expenses in 2005 to that in 2009?
Your answer should be compact. 0.5. What is the ratio of the Expenses (in $) in Salary of employees in 2006 to that in 2007?
Provide a succinct answer. 0.86. What is the ratio of the Expenses (in $) of Custom duties in 2006 to that in 2007?
Offer a very short reply. 1.09. What is the ratio of the Expenses (in $) of Interest Payments in 2006 to that in 2007?
Provide a short and direct response. 0.86. What is the ratio of the Expenses (in $) in Other expenses in 2006 to that in 2007?
Your response must be concise. 0.86. What is the ratio of the Expenses (in $) in Salary of employees in 2006 to that in 2008?
Your response must be concise. 0.79. What is the ratio of the Expenses (in $) in Custom duties in 2006 to that in 2008?
Ensure brevity in your answer.  1.21. What is the ratio of the Expenses (in $) of Interest Payments in 2006 to that in 2008?
Offer a terse response. 0.22. What is the ratio of the Expenses (in $) of Other expenses in 2006 to that in 2008?
Provide a short and direct response. 0.64. What is the ratio of the Expenses (in $) of Salary of employees in 2006 to that in 2009?
Offer a very short reply. 0.62. What is the ratio of the Expenses (in $) in Custom duties in 2006 to that in 2009?
Ensure brevity in your answer.  0.88. What is the ratio of the Expenses (in $) in Interest Payments in 2006 to that in 2009?
Provide a succinct answer. 0.22. What is the ratio of the Expenses (in $) in Other expenses in 2006 to that in 2009?
Make the answer very short. 0.55. What is the ratio of the Expenses (in $) of Salary of employees in 2007 to that in 2008?
Offer a very short reply. 0.92. What is the ratio of the Expenses (in $) in Custom duties in 2007 to that in 2008?
Your response must be concise. 1.12. What is the ratio of the Expenses (in $) of Interest Payments in 2007 to that in 2008?
Offer a very short reply. 0.26. What is the ratio of the Expenses (in $) in Other expenses in 2007 to that in 2008?
Your answer should be very brief. 0.74. What is the ratio of the Expenses (in $) in Salary of employees in 2007 to that in 2009?
Provide a succinct answer. 0.72. What is the ratio of the Expenses (in $) in Custom duties in 2007 to that in 2009?
Your response must be concise. 0.81. What is the ratio of the Expenses (in $) of Interest Payments in 2007 to that in 2009?
Provide a succinct answer. 0.26. What is the ratio of the Expenses (in $) of Other expenses in 2007 to that in 2009?
Provide a short and direct response. 0.64. What is the ratio of the Expenses (in $) in Salary of employees in 2008 to that in 2009?
Keep it short and to the point. 0.78. What is the ratio of the Expenses (in $) of Custom duties in 2008 to that in 2009?
Your answer should be very brief. 0.73. What is the ratio of the Expenses (in $) of Other expenses in 2008 to that in 2009?
Keep it short and to the point. 0.87. What is the difference between the highest and the second highest Expenses (in $) in Salary of employees?
Your answer should be compact. 1.09e+09. What is the difference between the highest and the second highest Expenses (in $) in Custom duties?
Offer a terse response. 5.28e+07. What is the difference between the highest and the second highest Expenses (in $) of Interest Payments?
Give a very brief answer. 1.46e+07. What is the difference between the highest and the second highest Expenses (in $) of Other expenses?
Provide a short and direct response. 1.90e+09. What is the difference between the highest and the lowest Expenses (in $) in Salary of employees?
Keep it short and to the point. 2.90e+09. What is the difference between the highest and the lowest Expenses (in $) in Custom duties?
Provide a short and direct response. 1.01e+08. What is the difference between the highest and the lowest Expenses (in $) of Interest Payments?
Provide a succinct answer. 1.51e+09. What is the difference between the highest and the lowest Expenses (in $) of Other expenses?
Your answer should be very brief. 8.85e+09. 